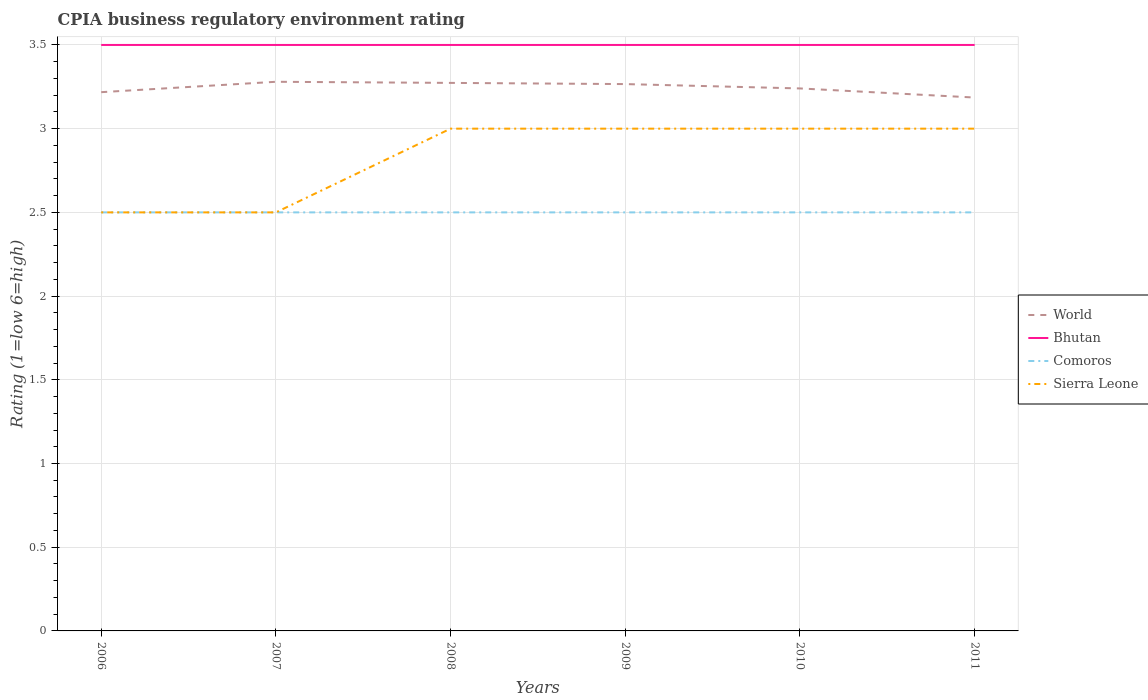How many different coloured lines are there?
Offer a terse response. 4. Is the number of lines equal to the number of legend labels?
Your response must be concise. Yes. Across all years, what is the maximum CPIA rating in Comoros?
Offer a terse response. 2.5. In which year was the CPIA rating in Sierra Leone maximum?
Make the answer very short. 2006. What is the difference between the highest and the lowest CPIA rating in Comoros?
Your answer should be very brief. 0. How many lines are there?
Your answer should be compact. 4. Does the graph contain any zero values?
Your answer should be very brief. No. How are the legend labels stacked?
Give a very brief answer. Vertical. What is the title of the graph?
Your answer should be very brief. CPIA business regulatory environment rating. Does "Armenia" appear as one of the legend labels in the graph?
Offer a very short reply. No. What is the label or title of the X-axis?
Offer a very short reply. Years. What is the label or title of the Y-axis?
Provide a succinct answer. Rating (1=low 6=high). What is the Rating (1=low 6=high) of World in 2006?
Your answer should be very brief. 3.22. What is the Rating (1=low 6=high) of Bhutan in 2006?
Ensure brevity in your answer.  3.5. What is the Rating (1=low 6=high) of Comoros in 2006?
Provide a succinct answer. 2.5. What is the Rating (1=low 6=high) of World in 2007?
Offer a terse response. 3.28. What is the Rating (1=low 6=high) in Comoros in 2007?
Provide a succinct answer. 2.5. What is the Rating (1=low 6=high) of World in 2008?
Provide a short and direct response. 3.27. What is the Rating (1=low 6=high) in Comoros in 2008?
Offer a terse response. 2.5. What is the Rating (1=low 6=high) of Sierra Leone in 2008?
Your answer should be very brief. 3. What is the Rating (1=low 6=high) of World in 2009?
Offer a very short reply. 3.27. What is the Rating (1=low 6=high) of Bhutan in 2009?
Ensure brevity in your answer.  3.5. What is the Rating (1=low 6=high) of Sierra Leone in 2009?
Your response must be concise. 3. What is the Rating (1=low 6=high) in World in 2010?
Provide a succinct answer. 3.24. What is the Rating (1=low 6=high) in Bhutan in 2010?
Keep it short and to the point. 3.5. What is the Rating (1=low 6=high) in World in 2011?
Offer a terse response. 3.19. What is the Rating (1=low 6=high) in Comoros in 2011?
Provide a short and direct response. 2.5. Across all years, what is the maximum Rating (1=low 6=high) in World?
Keep it short and to the point. 3.28. Across all years, what is the maximum Rating (1=low 6=high) of Bhutan?
Your response must be concise. 3.5. Across all years, what is the maximum Rating (1=low 6=high) of Sierra Leone?
Offer a terse response. 3. Across all years, what is the minimum Rating (1=low 6=high) of World?
Give a very brief answer. 3.19. Across all years, what is the minimum Rating (1=low 6=high) of Comoros?
Provide a short and direct response. 2.5. What is the total Rating (1=low 6=high) of World in the graph?
Provide a short and direct response. 19.46. What is the total Rating (1=low 6=high) of Comoros in the graph?
Your answer should be compact. 15. What is the total Rating (1=low 6=high) of Sierra Leone in the graph?
Give a very brief answer. 17. What is the difference between the Rating (1=low 6=high) of World in 2006 and that in 2007?
Ensure brevity in your answer.  -0.06. What is the difference between the Rating (1=low 6=high) in Sierra Leone in 2006 and that in 2007?
Provide a succinct answer. 0. What is the difference between the Rating (1=low 6=high) of World in 2006 and that in 2008?
Provide a short and direct response. -0.06. What is the difference between the Rating (1=low 6=high) of Sierra Leone in 2006 and that in 2008?
Offer a terse response. -0.5. What is the difference between the Rating (1=low 6=high) of World in 2006 and that in 2009?
Keep it short and to the point. -0.05. What is the difference between the Rating (1=low 6=high) of Bhutan in 2006 and that in 2009?
Your answer should be very brief. 0. What is the difference between the Rating (1=low 6=high) in Comoros in 2006 and that in 2009?
Provide a succinct answer. 0. What is the difference between the Rating (1=low 6=high) in World in 2006 and that in 2010?
Give a very brief answer. -0.02. What is the difference between the Rating (1=low 6=high) in Bhutan in 2006 and that in 2010?
Your answer should be compact. 0. What is the difference between the Rating (1=low 6=high) of Comoros in 2006 and that in 2010?
Offer a very short reply. 0. What is the difference between the Rating (1=low 6=high) of World in 2006 and that in 2011?
Provide a short and direct response. 0.03. What is the difference between the Rating (1=low 6=high) of Bhutan in 2006 and that in 2011?
Your answer should be compact. 0. What is the difference between the Rating (1=low 6=high) in Sierra Leone in 2006 and that in 2011?
Offer a terse response. -0.5. What is the difference between the Rating (1=low 6=high) in World in 2007 and that in 2008?
Keep it short and to the point. 0.01. What is the difference between the Rating (1=low 6=high) of Bhutan in 2007 and that in 2008?
Your answer should be compact. 0. What is the difference between the Rating (1=low 6=high) in Comoros in 2007 and that in 2008?
Your answer should be compact. 0. What is the difference between the Rating (1=low 6=high) in Sierra Leone in 2007 and that in 2008?
Your answer should be compact. -0.5. What is the difference between the Rating (1=low 6=high) of World in 2007 and that in 2009?
Provide a succinct answer. 0.01. What is the difference between the Rating (1=low 6=high) of Bhutan in 2007 and that in 2009?
Offer a terse response. 0. What is the difference between the Rating (1=low 6=high) of Comoros in 2007 and that in 2009?
Offer a very short reply. 0. What is the difference between the Rating (1=low 6=high) of Sierra Leone in 2007 and that in 2009?
Provide a succinct answer. -0.5. What is the difference between the Rating (1=low 6=high) in World in 2007 and that in 2010?
Your response must be concise. 0.04. What is the difference between the Rating (1=low 6=high) in World in 2007 and that in 2011?
Provide a succinct answer. 0.09. What is the difference between the Rating (1=low 6=high) of World in 2008 and that in 2009?
Ensure brevity in your answer.  0.01. What is the difference between the Rating (1=low 6=high) in Bhutan in 2008 and that in 2009?
Offer a terse response. 0. What is the difference between the Rating (1=low 6=high) in Comoros in 2008 and that in 2009?
Make the answer very short. 0. What is the difference between the Rating (1=low 6=high) in Sierra Leone in 2008 and that in 2009?
Offer a very short reply. 0. What is the difference between the Rating (1=low 6=high) of World in 2008 and that in 2010?
Ensure brevity in your answer.  0.03. What is the difference between the Rating (1=low 6=high) of Bhutan in 2008 and that in 2010?
Ensure brevity in your answer.  0. What is the difference between the Rating (1=low 6=high) in World in 2008 and that in 2011?
Offer a terse response. 0.09. What is the difference between the Rating (1=low 6=high) in Bhutan in 2008 and that in 2011?
Your response must be concise. 0. What is the difference between the Rating (1=low 6=high) in Comoros in 2008 and that in 2011?
Ensure brevity in your answer.  0. What is the difference between the Rating (1=low 6=high) in World in 2009 and that in 2010?
Make the answer very short. 0.03. What is the difference between the Rating (1=low 6=high) in Bhutan in 2009 and that in 2010?
Provide a succinct answer. 0. What is the difference between the Rating (1=low 6=high) of Comoros in 2009 and that in 2010?
Offer a terse response. 0. What is the difference between the Rating (1=low 6=high) in World in 2009 and that in 2011?
Offer a very short reply. 0.08. What is the difference between the Rating (1=low 6=high) of Comoros in 2009 and that in 2011?
Ensure brevity in your answer.  0. What is the difference between the Rating (1=low 6=high) of Sierra Leone in 2009 and that in 2011?
Offer a very short reply. 0. What is the difference between the Rating (1=low 6=high) of World in 2010 and that in 2011?
Your answer should be very brief. 0.05. What is the difference between the Rating (1=low 6=high) of Sierra Leone in 2010 and that in 2011?
Your response must be concise. 0. What is the difference between the Rating (1=low 6=high) in World in 2006 and the Rating (1=low 6=high) in Bhutan in 2007?
Offer a very short reply. -0.28. What is the difference between the Rating (1=low 6=high) of World in 2006 and the Rating (1=low 6=high) of Comoros in 2007?
Your answer should be compact. 0.72. What is the difference between the Rating (1=low 6=high) of World in 2006 and the Rating (1=low 6=high) of Sierra Leone in 2007?
Your answer should be compact. 0.72. What is the difference between the Rating (1=low 6=high) in Bhutan in 2006 and the Rating (1=low 6=high) in Comoros in 2007?
Keep it short and to the point. 1. What is the difference between the Rating (1=low 6=high) in World in 2006 and the Rating (1=low 6=high) in Bhutan in 2008?
Offer a very short reply. -0.28. What is the difference between the Rating (1=low 6=high) of World in 2006 and the Rating (1=low 6=high) of Comoros in 2008?
Your answer should be compact. 0.72. What is the difference between the Rating (1=low 6=high) in World in 2006 and the Rating (1=low 6=high) in Sierra Leone in 2008?
Your answer should be very brief. 0.22. What is the difference between the Rating (1=low 6=high) of Bhutan in 2006 and the Rating (1=low 6=high) of Comoros in 2008?
Keep it short and to the point. 1. What is the difference between the Rating (1=low 6=high) in Bhutan in 2006 and the Rating (1=low 6=high) in Sierra Leone in 2008?
Provide a succinct answer. 0.5. What is the difference between the Rating (1=low 6=high) in Comoros in 2006 and the Rating (1=low 6=high) in Sierra Leone in 2008?
Provide a succinct answer. -0.5. What is the difference between the Rating (1=low 6=high) in World in 2006 and the Rating (1=low 6=high) in Bhutan in 2009?
Offer a very short reply. -0.28. What is the difference between the Rating (1=low 6=high) in World in 2006 and the Rating (1=low 6=high) in Comoros in 2009?
Give a very brief answer. 0.72. What is the difference between the Rating (1=low 6=high) of World in 2006 and the Rating (1=low 6=high) of Sierra Leone in 2009?
Offer a very short reply. 0.22. What is the difference between the Rating (1=low 6=high) of Bhutan in 2006 and the Rating (1=low 6=high) of Sierra Leone in 2009?
Ensure brevity in your answer.  0.5. What is the difference between the Rating (1=low 6=high) of Comoros in 2006 and the Rating (1=low 6=high) of Sierra Leone in 2009?
Make the answer very short. -0.5. What is the difference between the Rating (1=low 6=high) in World in 2006 and the Rating (1=low 6=high) in Bhutan in 2010?
Offer a very short reply. -0.28. What is the difference between the Rating (1=low 6=high) of World in 2006 and the Rating (1=low 6=high) of Comoros in 2010?
Your answer should be compact. 0.72. What is the difference between the Rating (1=low 6=high) in World in 2006 and the Rating (1=low 6=high) in Sierra Leone in 2010?
Offer a very short reply. 0.22. What is the difference between the Rating (1=low 6=high) in Bhutan in 2006 and the Rating (1=low 6=high) in Sierra Leone in 2010?
Give a very brief answer. 0.5. What is the difference between the Rating (1=low 6=high) of Comoros in 2006 and the Rating (1=low 6=high) of Sierra Leone in 2010?
Provide a short and direct response. -0.5. What is the difference between the Rating (1=low 6=high) of World in 2006 and the Rating (1=low 6=high) of Bhutan in 2011?
Offer a terse response. -0.28. What is the difference between the Rating (1=low 6=high) in World in 2006 and the Rating (1=low 6=high) in Comoros in 2011?
Provide a succinct answer. 0.72. What is the difference between the Rating (1=low 6=high) in World in 2006 and the Rating (1=low 6=high) in Sierra Leone in 2011?
Offer a terse response. 0.22. What is the difference between the Rating (1=low 6=high) in Bhutan in 2006 and the Rating (1=low 6=high) in Sierra Leone in 2011?
Provide a succinct answer. 0.5. What is the difference between the Rating (1=low 6=high) of Comoros in 2006 and the Rating (1=low 6=high) of Sierra Leone in 2011?
Keep it short and to the point. -0.5. What is the difference between the Rating (1=low 6=high) in World in 2007 and the Rating (1=low 6=high) in Bhutan in 2008?
Give a very brief answer. -0.22. What is the difference between the Rating (1=low 6=high) of World in 2007 and the Rating (1=low 6=high) of Comoros in 2008?
Give a very brief answer. 0.78. What is the difference between the Rating (1=low 6=high) of World in 2007 and the Rating (1=low 6=high) of Sierra Leone in 2008?
Provide a short and direct response. 0.28. What is the difference between the Rating (1=low 6=high) in Bhutan in 2007 and the Rating (1=low 6=high) in Comoros in 2008?
Offer a very short reply. 1. What is the difference between the Rating (1=low 6=high) of Comoros in 2007 and the Rating (1=low 6=high) of Sierra Leone in 2008?
Your response must be concise. -0.5. What is the difference between the Rating (1=low 6=high) in World in 2007 and the Rating (1=low 6=high) in Bhutan in 2009?
Ensure brevity in your answer.  -0.22. What is the difference between the Rating (1=low 6=high) of World in 2007 and the Rating (1=low 6=high) of Comoros in 2009?
Ensure brevity in your answer.  0.78. What is the difference between the Rating (1=low 6=high) of World in 2007 and the Rating (1=low 6=high) of Sierra Leone in 2009?
Offer a terse response. 0.28. What is the difference between the Rating (1=low 6=high) in Bhutan in 2007 and the Rating (1=low 6=high) in Comoros in 2009?
Give a very brief answer. 1. What is the difference between the Rating (1=low 6=high) in World in 2007 and the Rating (1=low 6=high) in Bhutan in 2010?
Make the answer very short. -0.22. What is the difference between the Rating (1=low 6=high) in World in 2007 and the Rating (1=low 6=high) in Comoros in 2010?
Offer a terse response. 0.78. What is the difference between the Rating (1=low 6=high) in World in 2007 and the Rating (1=low 6=high) in Sierra Leone in 2010?
Your answer should be compact. 0.28. What is the difference between the Rating (1=low 6=high) in Bhutan in 2007 and the Rating (1=low 6=high) in Sierra Leone in 2010?
Ensure brevity in your answer.  0.5. What is the difference between the Rating (1=low 6=high) of Comoros in 2007 and the Rating (1=low 6=high) of Sierra Leone in 2010?
Offer a terse response. -0.5. What is the difference between the Rating (1=low 6=high) of World in 2007 and the Rating (1=low 6=high) of Bhutan in 2011?
Your answer should be very brief. -0.22. What is the difference between the Rating (1=low 6=high) of World in 2007 and the Rating (1=low 6=high) of Comoros in 2011?
Offer a very short reply. 0.78. What is the difference between the Rating (1=low 6=high) in World in 2007 and the Rating (1=low 6=high) in Sierra Leone in 2011?
Make the answer very short. 0.28. What is the difference between the Rating (1=low 6=high) of Bhutan in 2007 and the Rating (1=low 6=high) of Comoros in 2011?
Your answer should be compact. 1. What is the difference between the Rating (1=low 6=high) of Bhutan in 2007 and the Rating (1=low 6=high) of Sierra Leone in 2011?
Your answer should be compact. 0.5. What is the difference between the Rating (1=low 6=high) of Comoros in 2007 and the Rating (1=low 6=high) of Sierra Leone in 2011?
Make the answer very short. -0.5. What is the difference between the Rating (1=low 6=high) of World in 2008 and the Rating (1=low 6=high) of Bhutan in 2009?
Your response must be concise. -0.23. What is the difference between the Rating (1=low 6=high) of World in 2008 and the Rating (1=low 6=high) of Comoros in 2009?
Keep it short and to the point. 0.77. What is the difference between the Rating (1=low 6=high) in World in 2008 and the Rating (1=low 6=high) in Sierra Leone in 2009?
Your response must be concise. 0.27. What is the difference between the Rating (1=low 6=high) of Bhutan in 2008 and the Rating (1=low 6=high) of Comoros in 2009?
Your answer should be compact. 1. What is the difference between the Rating (1=low 6=high) in Bhutan in 2008 and the Rating (1=low 6=high) in Sierra Leone in 2009?
Offer a very short reply. 0.5. What is the difference between the Rating (1=low 6=high) of Comoros in 2008 and the Rating (1=low 6=high) of Sierra Leone in 2009?
Offer a very short reply. -0.5. What is the difference between the Rating (1=low 6=high) in World in 2008 and the Rating (1=low 6=high) in Bhutan in 2010?
Give a very brief answer. -0.23. What is the difference between the Rating (1=low 6=high) of World in 2008 and the Rating (1=low 6=high) of Comoros in 2010?
Ensure brevity in your answer.  0.77. What is the difference between the Rating (1=low 6=high) in World in 2008 and the Rating (1=low 6=high) in Sierra Leone in 2010?
Your answer should be compact. 0.27. What is the difference between the Rating (1=low 6=high) of Bhutan in 2008 and the Rating (1=low 6=high) of Comoros in 2010?
Provide a succinct answer. 1. What is the difference between the Rating (1=low 6=high) in Bhutan in 2008 and the Rating (1=low 6=high) in Sierra Leone in 2010?
Keep it short and to the point. 0.5. What is the difference between the Rating (1=low 6=high) of World in 2008 and the Rating (1=low 6=high) of Bhutan in 2011?
Provide a short and direct response. -0.23. What is the difference between the Rating (1=low 6=high) in World in 2008 and the Rating (1=low 6=high) in Comoros in 2011?
Offer a terse response. 0.77. What is the difference between the Rating (1=low 6=high) in World in 2008 and the Rating (1=low 6=high) in Sierra Leone in 2011?
Your answer should be compact. 0.27. What is the difference between the Rating (1=low 6=high) in Bhutan in 2008 and the Rating (1=low 6=high) in Sierra Leone in 2011?
Provide a succinct answer. 0.5. What is the difference between the Rating (1=low 6=high) in Comoros in 2008 and the Rating (1=low 6=high) in Sierra Leone in 2011?
Provide a succinct answer. -0.5. What is the difference between the Rating (1=low 6=high) of World in 2009 and the Rating (1=low 6=high) of Bhutan in 2010?
Your response must be concise. -0.23. What is the difference between the Rating (1=low 6=high) in World in 2009 and the Rating (1=low 6=high) in Comoros in 2010?
Your answer should be compact. 0.77. What is the difference between the Rating (1=low 6=high) of World in 2009 and the Rating (1=low 6=high) of Sierra Leone in 2010?
Offer a terse response. 0.27. What is the difference between the Rating (1=low 6=high) of Bhutan in 2009 and the Rating (1=low 6=high) of Sierra Leone in 2010?
Your answer should be compact. 0.5. What is the difference between the Rating (1=low 6=high) of Comoros in 2009 and the Rating (1=low 6=high) of Sierra Leone in 2010?
Give a very brief answer. -0.5. What is the difference between the Rating (1=low 6=high) of World in 2009 and the Rating (1=low 6=high) of Bhutan in 2011?
Your answer should be compact. -0.23. What is the difference between the Rating (1=low 6=high) of World in 2009 and the Rating (1=low 6=high) of Comoros in 2011?
Your answer should be compact. 0.77. What is the difference between the Rating (1=low 6=high) in World in 2009 and the Rating (1=low 6=high) in Sierra Leone in 2011?
Keep it short and to the point. 0.27. What is the difference between the Rating (1=low 6=high) of Bhutan in 2009 and the Rating (1=low 6=high) of Comoros in 2011?
Make the answer very short. 1. What is the difference between the Rating (1=low 6=high) of Comoros in 2009 and the Rating (1=low 6=high) of Sierra Leone in 2011?
Offer a terse response. -0.5. What is the difference between the Rating (1=low 6=high) in World in 2010 and the Rating (1=low 6=high) in Bhutan in 2011?
Keep it short and to the point. -0.26. What is the difference between the Rating (1=low 6=high) of World in 2010 and the Rating (1=low 6=high) of Comoros in 2011?
Your response must be concise. 0.74. What is the difference between the Rating (1=low 6=high) in World in 2010 and the Rating (1=low 6=high) in Sierra Leone in 2011?
Offer a very short reply. 0.24. What is the difference between the Rating (1=low 6=high) of Bhutan in 2010 and the Rating (1=low 6=high) of Sierra Leone in 2011?
Keep it short and to the point. 0.5. What is the average Rating (1=low 6=high) in World per year?
Provide a succinct answer. 3.24. What is the average Rating (1=low 6=high) of Sierra Leone per year?
Offer a very short reply. 2.83. In the year 2006, what is the difference between the Rating (1=low 6=high) in World and Rating (1=low 6=high) in Bhutan?
Ensure brevity in your answer.  -0.28. In the year 2006, what is the difference between the Rating (1=low 6=high) of World and Rating (1=low 6=high) of Comoros?
Offer a very short reply. 0.72. In the year 2006, what is the difference between the Rating (1=low 6=high) in World and Rating (1=low 6=high) in Sierra Leone?
Give a very brief answer. 0.72. In the year 2006, what is the difference between the Rating (1=low 6=high) of Bhutan and Rating (1=low 6=high) of Comoros?
Your answer should be compact. 1. In the year 2006, what is the difference between the Rating (1=low 6=high) of Bhutan and Rating (1=low 6=high) of Sierra Leone?
Your response must be concise. 1. In the year 2006, what is the difference between the Rating (1=low 6=high) in Comoros and Rating (1=low 6=high) in Sierra Leone?
Your response must be concise. 0. In the year 2007, what is the difference between the Rating (1=low 6=high) of World and Rating (1=low 6=high) of Bhutan?
Offer a terse response. -0.22. In the year 2007, what is the difference between the Rating (1=low 6=high) of World and Rating (1=low 6=high) of Comoros?
Offer a very short reply. 0.78. In the year 2007, what is the difference between the Rating (1=low 6=high) of World and Rating (1=low 6=high) of Sierra Leone?
Offer a very short reply. 0.78. In the year 2007, what is the difference between the Rating (1=low 6=high) in Bhutan and Rating (1=low 6=high) in Comoros?
Your answer should be very brief. 1. In the year 2007, what is the difference between the Rating (1=low 6=high) in Bhutan and Rating (1=low 6=high) in Sierra Leone?
Your answer should be very brief. 1. In the year 2007, what is the difference between the Rating (1=low 6=high) in Comoros and Rating (1=low 6=high) in Sierra Leone?
Ensure brevity in your answer.  0. In the year 2008, what is the difference between the Rating (1=low 6=high) of World and Rating (1=low 6=high) of Bhutan?
Offer a very short reply. -0.23. In the year 2008, what is the difference between the Rating (1=low 6=high) of World and Rating (1=low 6=high) of Comoros?
Make the answer very short. 0.77. In the year 2008, what is the difference between the Rating (1=low 6=high) of World and Rating (1=low 6=high) of Sierra Leone?
Make the answer very short. 0.27. In the year 2008, what is the difference between the Rating (1=low 6=high) of Bhutan and Rating (1=low 6=high) of Comoros?
Provide a succinct answer. 1. In the year 2008, what is the difference between the Rating (1=low 6=high) in Bhutan and Rating (1=low 6=high) in Sierra Leone?
Your answer should be very brief. 0.5. In the year 2009, what is the difference between the Rating (1=low 6=high) in World and Rating (1=low 6=high) in Bhutan?
Keep it short and to the point. -0.23. In the year 2009, what is the difference between the Rating (1=low 6=high) in World and Rating (1=low 6=high) in Comoros?
Make the answer very short. 0.77. In the year 2009, what is the difference between the Rating (1=low 6=high) in World and Rating (1=low 6=high) in Sierra Leone?
Your response must be concise. 0.27. In the year 2009, what is the difference between the Rating (1=low 6=high) in Bhutan and Rating (1=low 6=high) in Sierra Leone?
Ensure brevity in your answer.  0.5. In the year 2009, what is the difference between the Rating (1=low 6=high) in Comoros and Rating (1=low 6=high) in Sierra Leone?
Provide a short and direct response. -0.5. In the year 2010, what is the difference between the Rating (1=low 6=high) in World and Rating (1=low 6=high) in Bhutan?
Make the answer very short. -0.26. In the year 2010, what is the difference between the Rating (1=low 6=high) in World and Rating (1=low 6=high) in Comoros?
Your answer should be compact. 0.74. In the year 2010, what is the difference between the Rating (1=low 6=high) in World and Rating (1=low 6=high) in Sierra Leone?
Give a very brief answer. 0.24. In the year 2010, what is the difference between the Rating (1=low 6=high) in Bhutan and Rating (1=low 6=high) in Comoros?
Ensure brevity in your answer.  1. In the year 2010, what is the difference between the Rating (1=low 6=high) in Bhutan and Rating (1=low 6=high) in Sierra Leone?
Your response must be concise. 0.5. In the year 2010, what is the difference between the Rating (1=low 6=high) in Comoros and Rating (1=low 6=high) in Sierra Leone?
Give a very brief answer. -0.5. In the year 2011, what is the difference between the Rating (1=low 6=high) of World and Rating (1=low 6=high) of Bhutan?
Offer a terse response. -0.31. In the year 2011, what is the difference between the Rating (1=low 6=high) of World and Rating (1=low 6=high) of Comoros?
Keep it short and to the point. 0.69. In the year 2011, what is the difference between the Rating (1=low 6=high) in World and Rating (1=low 6=high) in Sierra Leone?
Make the answer very short. 0.19. In the year 2011, what is the difference between the Rating (1=low 6=high) in Comoros and Rating (1=low 6=high) in Sierra Leone?
Your answer should be very brief. -0.5. What is the ratio of the Rating (1=low 6=high) in World in 2006 to that in 2007?
Provide a succinct answer. 0.98. What is the ratio of the Rating (1=low 6=high) in Comoros in 2006 to that in 2007?
Make the answer very short. 1. What is the ratio of the Rating (1=low 6=high) of World in 2006 to that in 2008?
Give a very brief answer. 0.98. What is the ratio of the Rating (1=low 6=high) in Sierra Leone in 2006 to that in 2008?
Offer a very short reply. 0.83. What is the ratio of the Rating (1=low 6=high) in World in 2006 to that in 2009?
Ensure brevity in your answer.  0.99. What is the ratio of the Rating (1=low 6=high) of Comoros in 2006 to that in 2009?
Keep it short and to the point. 1. What is the ratio of the Rating (1=low 6=high) of World in 2006 to that in 2010?
Offer a terse response. 0.99. What is the ratio of the Rating (1=low 6=high) of Bhutan in 2006 to that in 2010?
Your response must be concise. 1. What is the ratio of the Rating (1=low 6=high) of Sierra Leone in 2006 to that in 2010?
Provide a short and direct response. 0.83. What is the ratio of the Rating (1=low 6=high) of World in 2006 to that in 2011?
Give a very brief answer. 1.01. What is the ratio of the Rating (1=low 6=high) in Sierra Leone in 2006 to that in 2011?
Your response must be concise. 0.83. What is the ratio of the Rating (1=low 6=high) of Comoros in 2007 to that in 2008?
Your answer should be very brief. 1. What is the ratio of the Rating (1=low 6=high) of World in 2007 to that in 2009?
Offer a very short reply. 1. What is the ratio of the Rating (1=low 6=high) in Bhutan in 2007 to that in 2009?
Make the answer very short. 1. What is the ratio of the Rating (1=low 6=high) in Comoros in 2007 to that in 2009?
Ensure brevity in your answer.  1. What is the ratio of the Rating (1=low 6=high) in Sierra Leone in 2007 to that in 2009?
Your answer should be compact. 0.83. What is the ratio of the Rating (1=low 6=high) in World in 2007 to that in 2010?
Give a very brief answer. 1.01. What is the ratio of the Rating (1=low 6=high) of Bhutan in 2007 to that in 2010?
Provide a succinct answer. 1. What is the ratio of the Rating (1=low 6=high) of Comoros in 2007 to that in 2010?
Keep it short and to the point. 1. What is the ratio of the Rating (1=low 6=high) in World in 2007 to that in 2011?
Your answer should be compact. 1.03. What is the ratio of the Rating (1=low 6=high) of Bhutan in 2007 to that in 2011?
Ensure brevity in your answer.  1. What is the ratio of the Rating (1=low 6=high) in Comoros in 2007 to that in 2011?
Provide a succinct answer. 1. What is the ratio of the Rating (1=low 6=high) in Sierra Leone in 2007 to that in 2011?
Your answer should be very brief. 0.83. What is the ratio of the Rating (1=low 6=high) of World in 2008 to that in 2009?
Your answer should be compact. 1. What is the ratio of the Rating (1=low 6=high) of Bhutan in 2008 to that in 2009?
Keep it short and to the point. 1. What is the ratio of the Rating (1=low 6=high) of Comoros in 2008 to that in 2009?
Keep it short and to the point. 1. What is the ratio of the Rating (1=low 6=high) in World in 2008 to that in 2010?
Ensure brevity in your answer.  1.01. What is the ratio of the Rating (1=low 6=high) in Bhutan in 2008 to that in 2010?
Ensure brevity in your answer.  1. What is the ratio of the Rating (1=low 6=high) of Sierra Leone in 2008 to that in 2010?
Offer a terse response. 1. What is the ratio of the Rating (1=low 6=high) of World in 2008 to that in 2011?
Your answer should be very brief. 1.03. What is the ratio of the Rating (1=low 6=high) of Bhutan in 2009 to that in 2010?
Your answer should be very brief. 1. What is the ratio of the Rating (1=low 6=high) of Sierra Leone in 2009 to that in 2010?
Keep it short and to the point. 1. What is the ratio of the Rating (1=low 6=high) in World in 2009 to that in 2011?
Make the answer very short. 1.03. What is the ratio of the Rating (1=low 6=high) of Bhutan in 2009 to that in 2011?
Your answer should be very brief. 1. What is the ratio of the Rating (1=low 6=high) of Sierra Leone in 2009 to that in 2011?
Ensure brevity in your answer.  1. What is the ratio of the Rating (1=low 6=high) of World in 2010 to that in 2011?
Keep it short and to the point. 1.02. What is the ratio of the Rating (1=low 6=high) of Bhutan in 2010 to that in 2011?
Your answer should be compact. 1. What is the ratio of the Rating (1=low 6=high) of Comoros in 2010 to that in 2011?
Give a very brief answer. 1. What is the ratio of the Rating (1=low 6=high) in Sierra Leone in 2010 to that in 2011?
Ensure brevity in your answer.  1. What is the difference between the highest and the second highest Rating (1=low 6=high) in World?
Provide a short and direct response. 0.01. What is the difference between the highest and the second highest Rating (1=low 6=high) in Bhutan?
Provide a succinct answer. 0. What is the difference between the highest and the second highest Rating (1=low 6=high) in Comoros?
Offer a terse response. 0. What is the difference between the highest and the lowest Rating (1=low 6=high) of World?
Your answer should be very brief. 0.09. What is the difference between the highest and the lowest Rating (1=low 6=high) in Bhutan?
Ensure brevity in your answer.  0. What is the difference between the highest and the lowest Rating (1=low 6=high) in Comoros?
Give a very brief answer. 0. What is the difference between the highest and the lowest Rating (1=low 6=high) of Sierra Leone?
Ensure brevity in your answer.  0.5. 